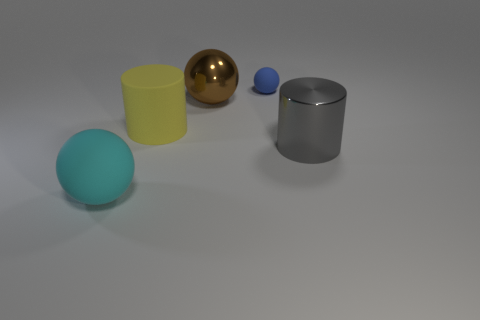What is the size of the other matte object that is the same shape as the blue rubber thing?
Give a very brief answer. Large. How many brown balls have the same material as the gray cylinder?
Your answer should be compact. 1. There is a large rubber cylinder; is its color the same as the large sphere on the left side of the large yellow rubber cylinder?
Offer a very short reply. No. Are there more big matte cylinders than objects?
Make the answer very short. No. What is the color of the small sphere?
Your answer should be very brief. Blue. Do the rubber sphere in front of the big gray metal thing and the big matte cylinder have the same color?
Keep it short and to the point. No. What number of other rubber balls have the same color as the small sphere?
Provide a succinct answer. 0. Do the shiny thing to the right of the large brown metallic thing and the cyan matte object have the same shape?
Keep it short and to the point. No. Is the number of metallic spheres in front of the big cyan matte object less than the number of rubber things that are on the right side of the blue matte ball?
Ensure brevity in your answer.  No. There is a cylinder that is behind the gray metal object; what is its material?
Offer a terse response. Rubber. 